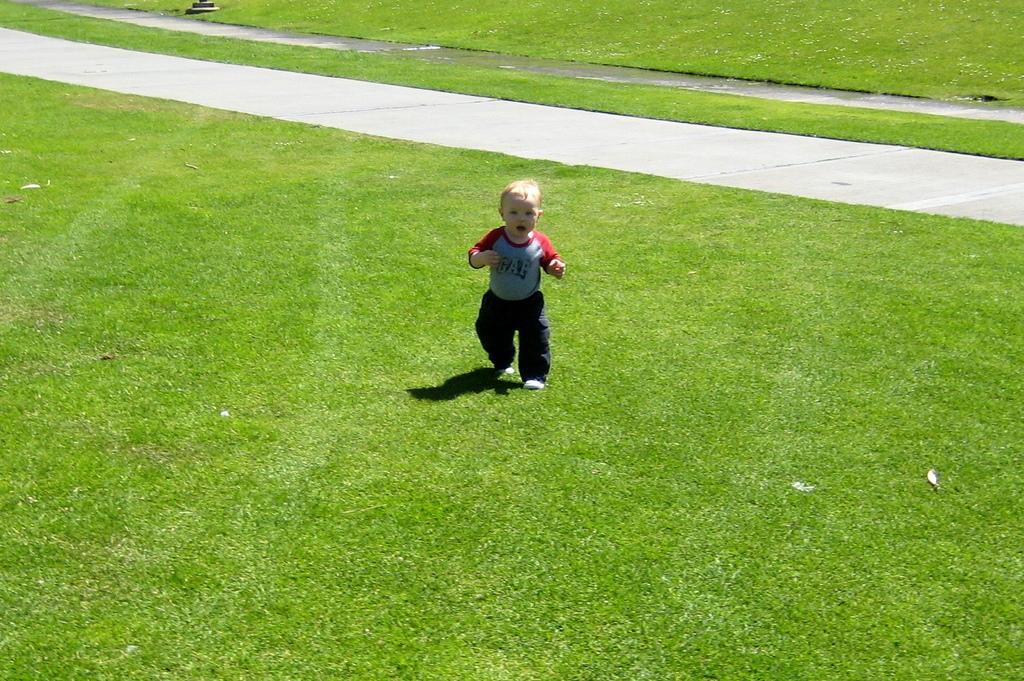Please provide a concise description of this image. In this image I can see the child on the grass. The child is wearing the blue, red and black color dress. To the side I can see the road. 